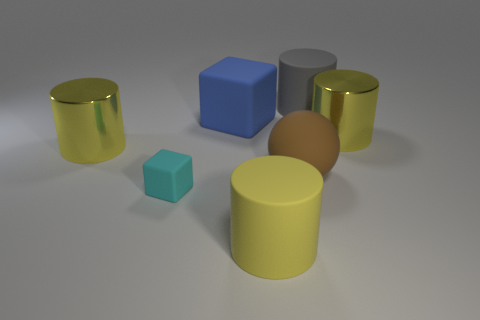Subtract all brown cubes. How many yellow cylinders are left? 3 Subtract 1 cylinders. How many cylinders are left? 3 Add 3 gray cylinders. How many objects exist? 10 Subtract all spheres. How many objects are left? 6 Add 1 big things. How many big things are left? 7 Add 1 tiny cyan rubber blocks. How many tiny cyan rubber blocks exist? 2 Subtract 1 blue blocks. How many objects are left? 6 Subtract all purple spheres. Subtract all large metal objects. How many objects are left? 5 